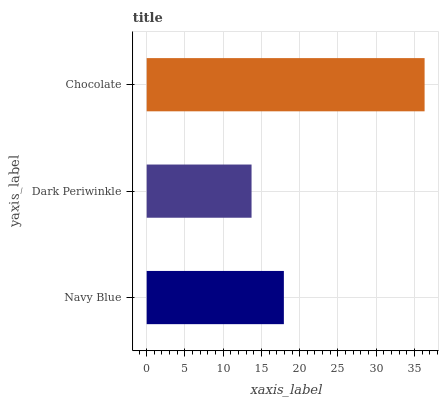Is Dark Periwinkle the minimum?
Answer yes or no. Yes. Is Chocolate the maximum?
Answer yes or no. Yes. Is Chocolate the minimum?
Answer yes or no. No. Is Dark Periwinkle the maximum?
Answer yes or no. No. Is Chocolate greater than Dark Periwinkle?
Answer yes or no. Yes. Is Dark Periwinkle less than Chocolate?
Answer yes or no. Yes. Is Dark Periwinkle greater than Chocolate?
Answer yes or no. No. Is Chocolate less than Dark Periwinkle?
Answer yes or no. No. Is Navy Blue the high median?
Answer yes or no. Yes. Is Navy Blue the low median?
Answer yes or no. Yes. Is Chocolate the high median?
Answer yes or no. No. Is Chocolate the low median?
Answer yes or no. No. 